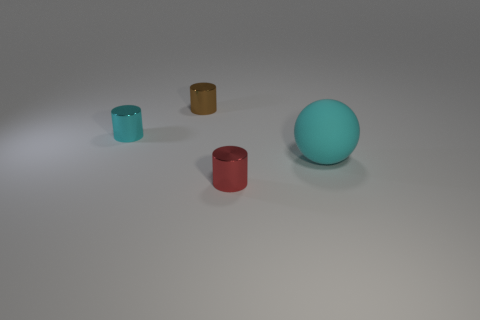Is there a brown thing of the same size as the red thing?
Give a very brief answer. Yes. There is a red metallic thing; is it the same shape as the cyan thing that is on the left side of the matte ball?
Offer a very short reply. Yes. Is the size of the cyan thing right of the tiny red metal thing the same as the cyan object behind the large cyan sphere?
Ensure brevity in your answer.  No. How many other objects are the same shape as the red metallic thing?
Provide a short and direct response. 2. What material is the small cylinder in front of the cyan thing right of the red shiny cylinder made of?
Your response must be concise. Metal. What number of metal objects are large balls or small things?
Your answer should be compact. 3. Is there anything else that is the same material as the sphere?
Give a very brief answer. No. There is a object that is to the right of the tiny red metal cylinder; is there a tiny thing in front of it?
Give a very brief answer. Yes. How many things are things right of the tiny red metallic thing or tiny shiny objects in front of the large cyan object?
Provide a short and direct response. 2. Is there any other thing that is the same color as the rubber object?
Provide a succinct answer. Yes. 